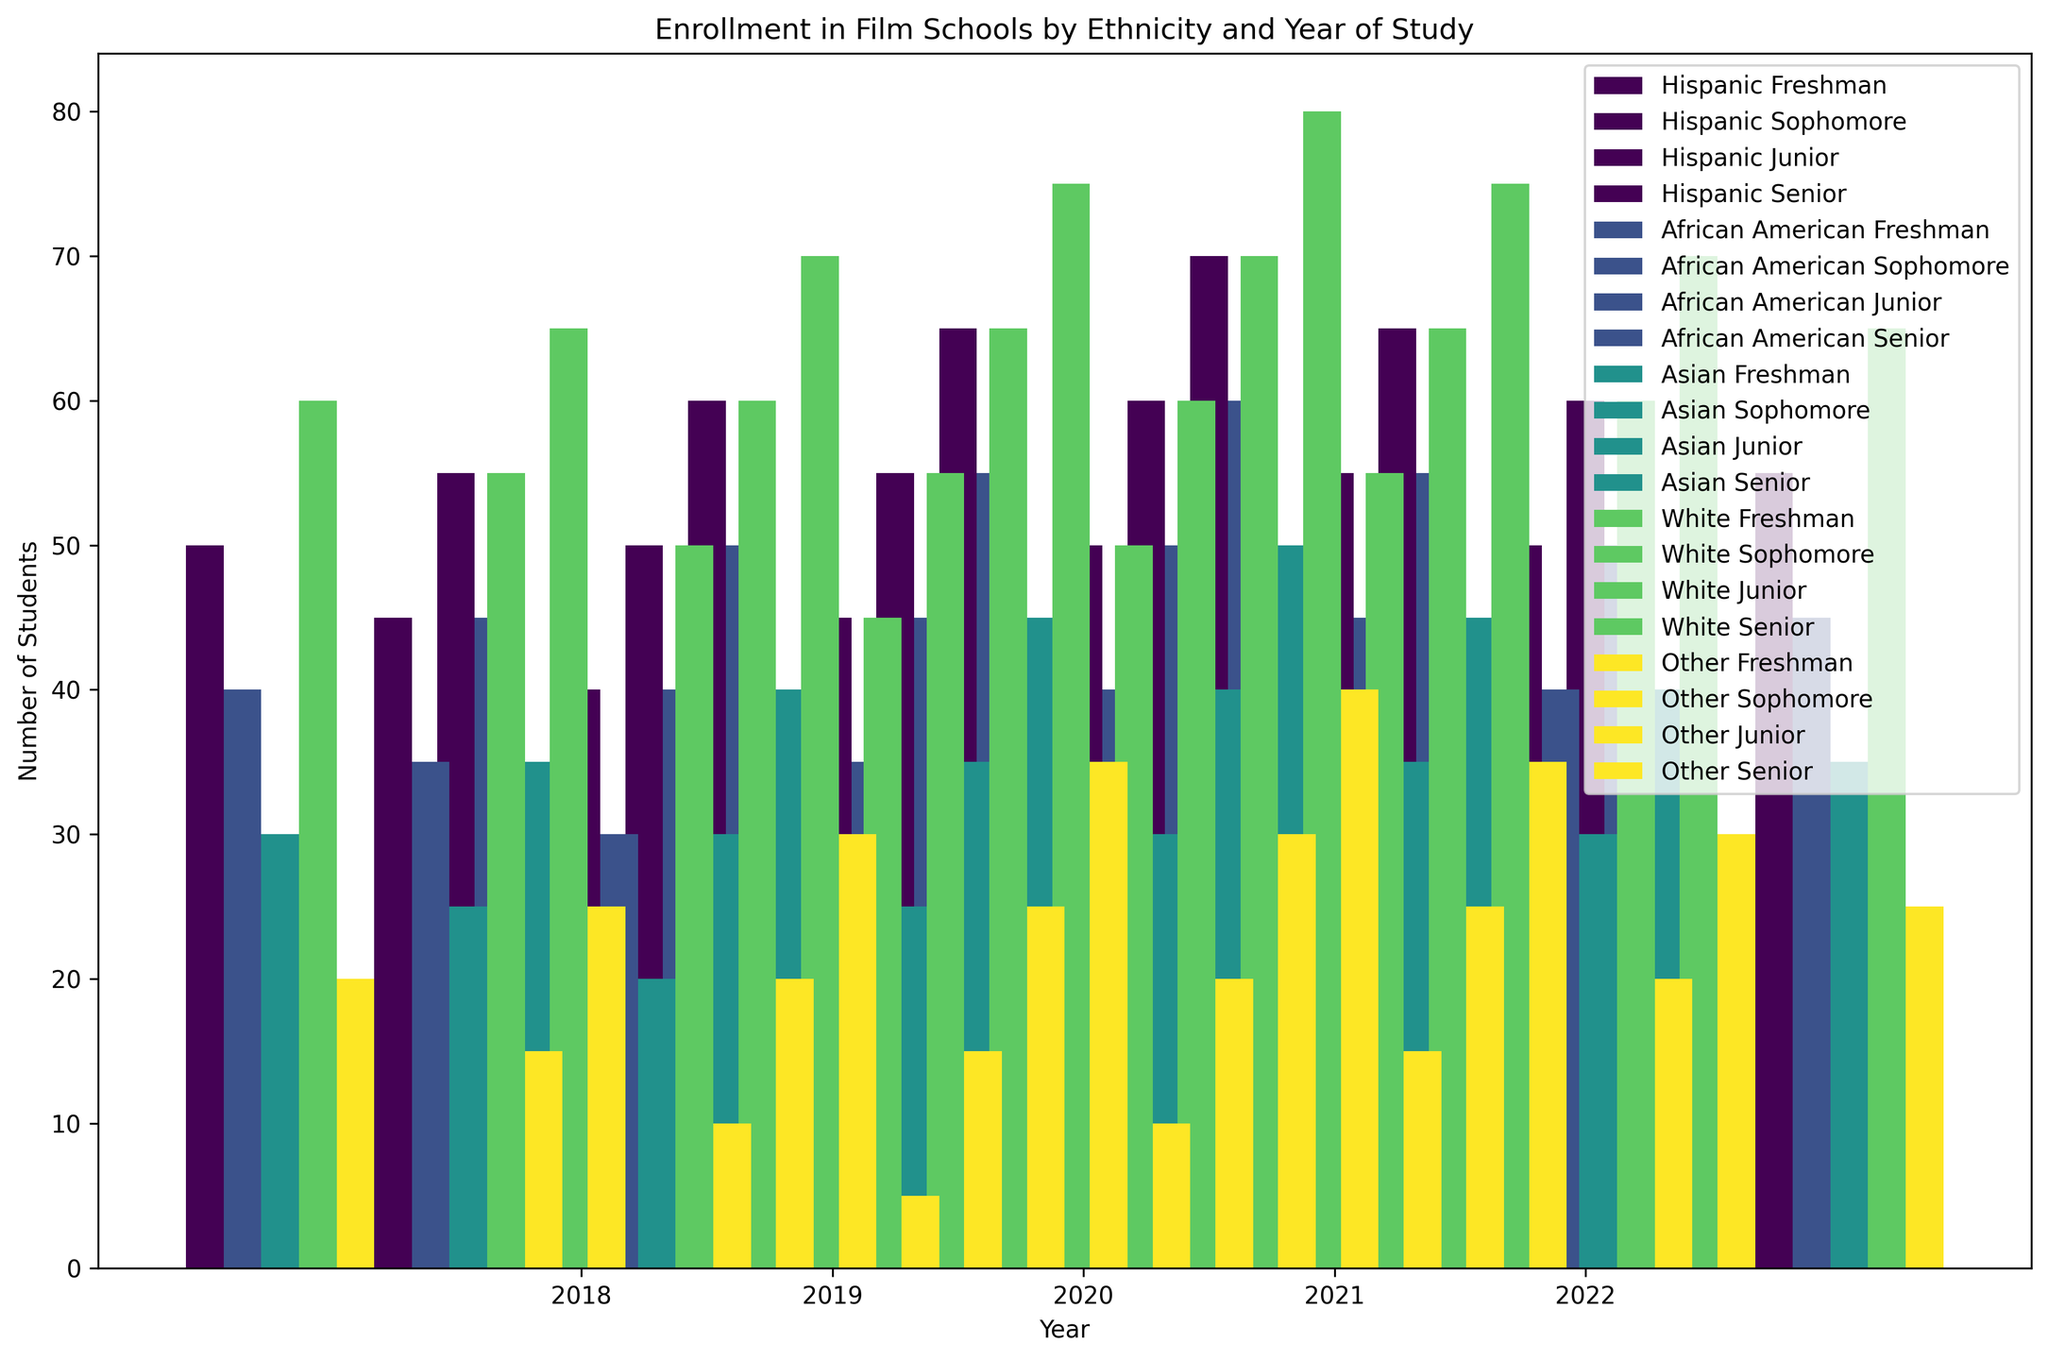What ethnicity had the highest number of Freshmen in 2021? Look at the bars for the year 2021 and compare the heights of the bars labeled 'Freshman' for each ethnicity. The highest bar indicates the ethnicity with the highest number of Freshmen.
Answer: White Which group showed the most significant increase in Freshman enrollment from 2018 to 2022? Compare the bars for 'Freshman' from 2018 and 2022 for each ethnicity. To find the most significant increase, calculate the difference in heights between 2022 and 2018 for each group.
Answer: White Between Hispanic Sophomores and African American Juniors in 2019, which group had more students? For the year 2019, compare the heights of the bars for Hispanic Sophomores and African American Juniors.
Answer: Hispanic Sophomores How did the enrollment of Asian Seniors change from 2018 to 2020? Compare the height of the bars representing Asian Seniors between 2018 and 2020 to see the trend.
Answer: Increased What is the total number of students enrolled as Freshmen in 2022 across all ethnicities? Sum the heights of all the bars labeled 'Freshman' for the year 2022 across all ethnicities (Hispanic, African American, Asian, White, Other).
Answer: 295 Which year had the highest overall enrollment for African American students? Compare the total heights of all bars (Freshman, Sophomore, Junior, Senior) for African American students across all years.
Answer: 2022 Are there more Asian Sophomores or Asian Juniors in 2021? Compare the heights of the bars for Asian Sophomores and Asian Juniors in the year 2021.
Answer: Asian Sophomores What is the trend in the enrollment of White Seniors from 2018 to 2022? Observe the heights of the bars representing White Seniors from 2018 to 2022 and determine if the bars are increasing, decreasing, or stable.
Answer: Increasing How did the number of African American Freshmen change from 2018 to 2019? Compare the height of the bars for African American Freshmen in 2018 and 2019.
Answer: Increased Comparing Hispanic Seniors in 2020 with White Juniors in 2018, which group had more students? Compare the heights of the bars representing Hispanic Seniors in 2020 with White Juniors in 2018.
Answer: White Juniors 